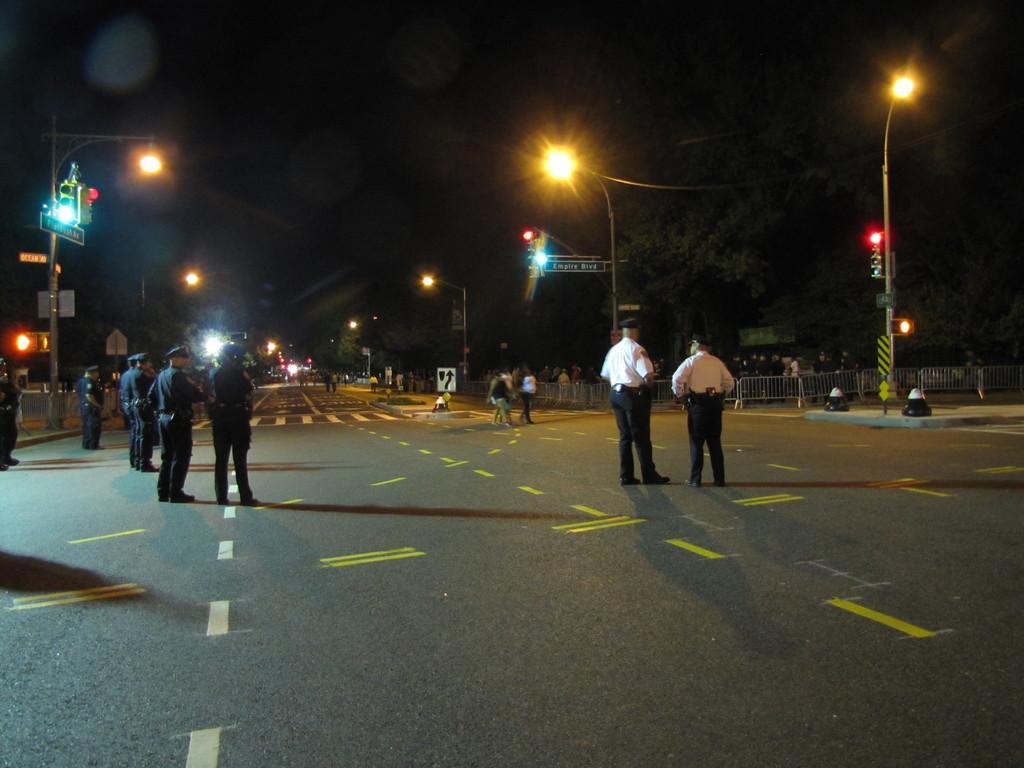Can you describe this image briefly? At the bottom of the image on the road there are few people standing. Behind them there is fencing on the footpath. And also there are poles with traffic signals, lights and sign boards. And also there are trees. And there is a dark background. 